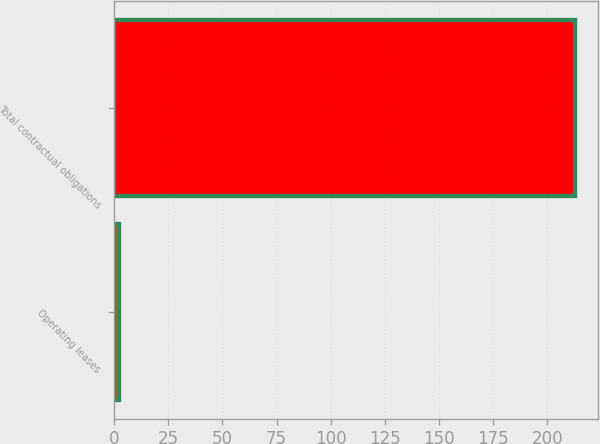Convert chart to OTSL. <chart><loc_0><loc_0><loc_500><loc_500><bar_chart><fcel>Operating leases<fcel>Total contractual obligations<nl><fcel>2.1<fcel>212.9<nl></chart> 